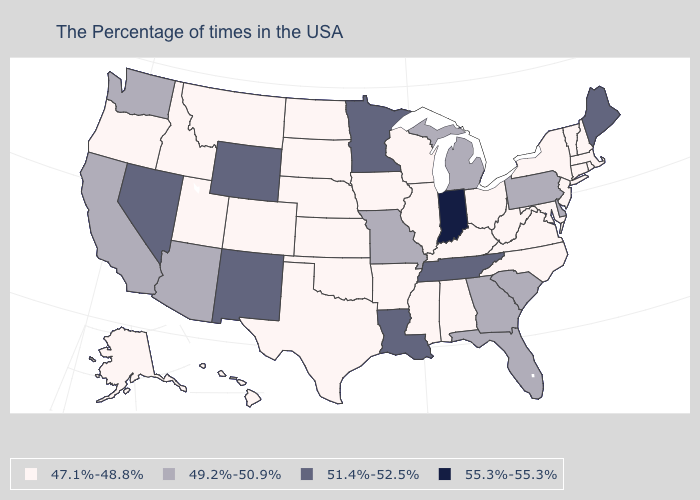Name the states that have a value in the range 51.4%-52.5%?
Keep it brief. Maine, Tennessee, Louisiana, Minnesota, Wyoming, New Mexico, Nevada. Name the states that have a value in the range 47.1%-48.8%?
Concise answer only. Massachusetts, Rhode Island, New Hampshire, Vermont, Connecticut, New York, New Jersey, Maryland, Virginia, North Carolina, West Virginia, Ohio, Kentucky, Alabama, Wisconsin, Illinois, Mississippi, Arkansas, Iowa, Kansas, Nebraska, Oklahoma, Texas, South Dakota, North Dakota, Colorado, Utah, Montana, Idaho, Oregon, Alaska, Hawaii. Name the states that have a value in the range 47.1%-48.8%?
Be succinct. Massachusetts, Rhode Island, New Hampshire, Vermont, Connecticut, New York, New Jersey, Maryland, Virginia, North Carolina, West Virginia, Ohio, Kentucky, Alabama, Wisconsin, Illinois, Mississippi, Arkansas, Iowa, Kansas, Nebraska, Oklahoma, Texas, South Dakota, North Dakota, Colorado, Utah, Montana, Idaho, Oregon, Alaska, Hawaii. Is the legend a continuous bar?
Concise answer only. No. Among the states that border Pennsylvania , which have the lowest value?
Keep it brief. New York, New Jersey, Maryland, West Virginia, Ohio. Does the map have missing data?
Answer briefly. No. Name the states that have a value in the range 51.4%-52.5%?
Short answer required. Maine, Tennessee, Louisiana, Minnesota, Wyoming, New Mexico, Nevada. What is the value of Massachusetts?
Concise answer only. 47.1%-48.8%. Which states hav the highest value in the West?
Quick response, please. Wyoming, New Mexico, Nevada. Which states have the lowest value in the West?
Write a very short answer. Colorado, Utah, Montana, Idaho, Oregon, Alaska, Hawaii. Name the states that have a value in the range 51.4%-52.5%?
Give a very brief answer. Maine, Tennessee, Louisiana, Minnesota, Wyoming, New Mexico, Nevada. Which states have the lowest value in the USA?
Write a very short answer. Massachusetts, Rhode Island, New Hampshire, Vermont, Connecticut, New York, New Jersey, Maryland, Virginia, North Carolina, West Virginia, Ohio, Kentucky, Alabama, Wisconsin, Illinois, Mississippi, Arkansas, Iowa, Kansas, Nebraska, Oklahoma, Texas, South Dakota, North Dakota, Colorado, Utah, Montana, Idaho, Oregon, Alaska, Hawaii. Does the first symbol in the legend represent the smallest category?
Concise answer only. Yes. Name the states that have a value in the range 55.3%-55.3%?
Be succinct. Indiana. What is the highest value in the USA?
Keep it brief. 55.3%-55.3%. 